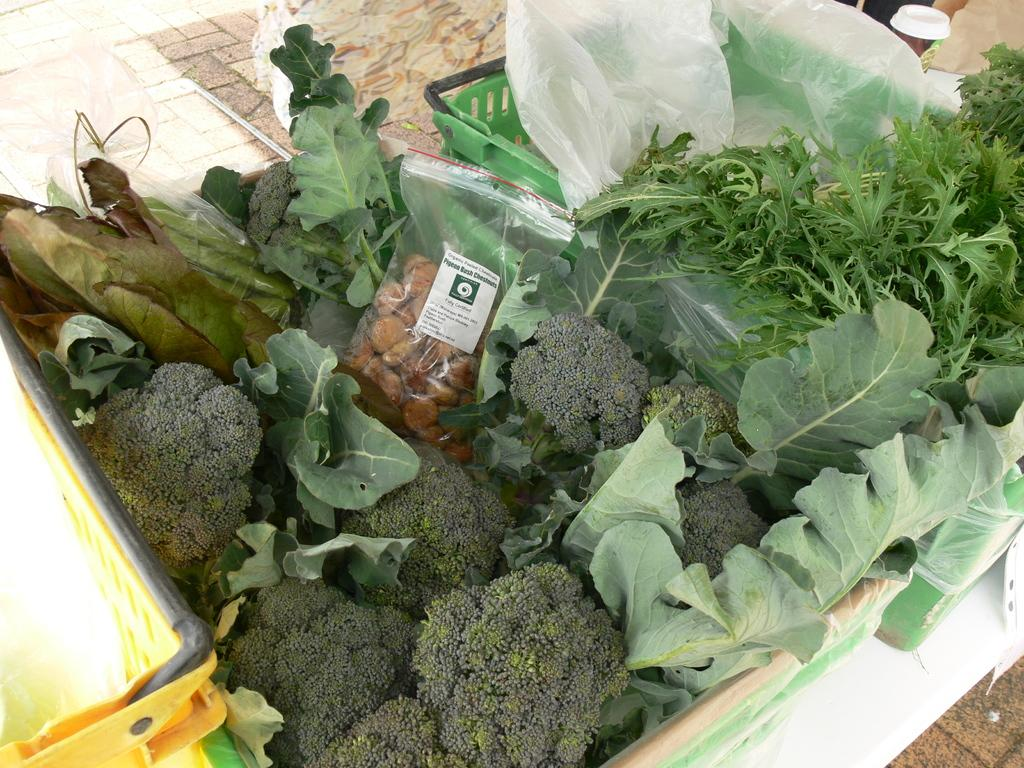What types of food can be seen in the image? There are food items in the image. Can you describe the packaging of one of the food items? There is food in a packet in the image. What is located on the left side of the image? There is a yellow color basket on the left side of the image. What type of appliance is being used for the voyage in the image? There is no voyage or appliance present in the image. 